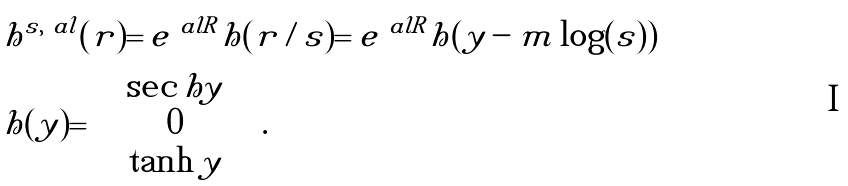<formula> <loc_0><loc_0><loc_500><loc_500>& h ^ { s , \ a l } ( r ) = e ^ { \ a l R } h ( r / s ) = e ^ { \ a l R } \tilde { h } ( y - m \log ( s ) ) \\ & \tilde { h } ( y ) = \left ( \begin{array} { c } \sec h y \\ 0 \\ \tanh y \\ \end{array} \right ) .</formula> 